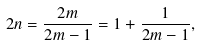<formula> <loc_0><loc_0><loc_500><loc_500>2 n = \frac { 2 m } { 2 m - 1 } = 1 + \frac { 1 } { 2 m - 1 } ,</formula> 